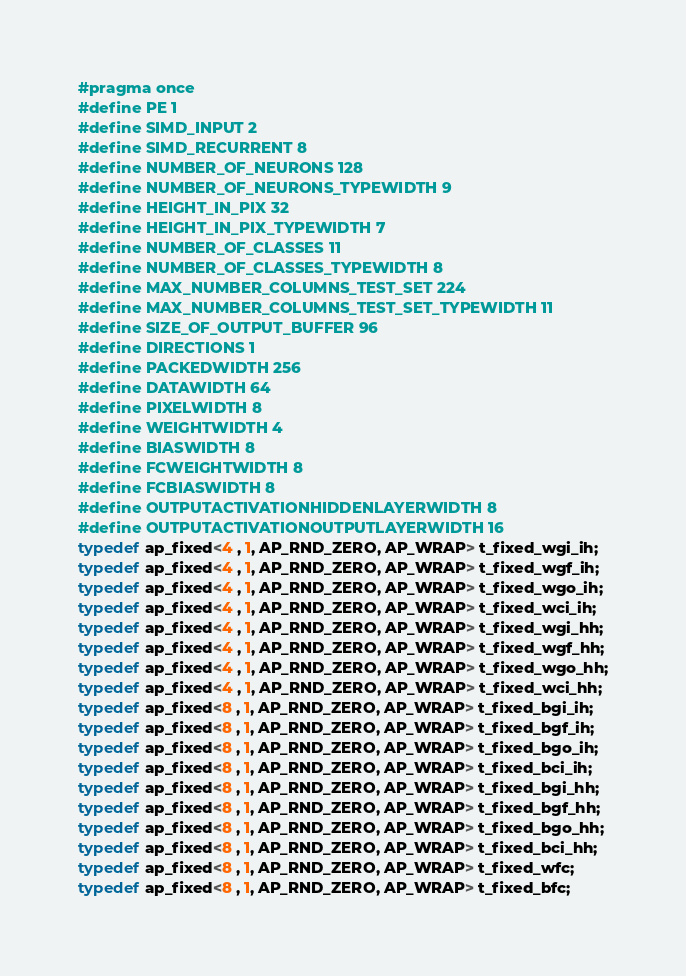<code> <loc_0><loc_0><loc_500><loc_500><_C++_>#pragma once
#define PE 1
#define SIMD_INPUT 2
#define SIMD_RECURRENT 8
#define NUMBER_OF_NEURONS 128
#define NUMBER_OF_NEURONS_TYPEWIDTH 9
#define HEIGHT_IN_PIX 32
#define HEIGHT_IN_PIX_TYPEWIDTH 7
#define NUMBER_OF_CLASSES 11
#define NUMBER_OF_CLASSES_TYPEWIDTH 8
#define MAX_NUMBER_COLUMNS_TEST_SET 224
#define MAX_NUMBER_COLUMNS_TEST_SET_TYPEWIDTH 11
#define SIZE_OF_OUTPUT_BUFFER 96
#define DIRECTIONS 1
#define PACKEDWIDTH 256
#define DATAWIDTH 64
#define PIXELWIDTH 8
#define WEIGHTWIDTH 4
#define BIASWIDTH 8
#define FCWEIGHTWIDTH 8
#define FCBIASWIDTH 8
#define OUTPUTACTIVATIONHIDDENLAYERWIDTH 8
#define OUTPUTACTIVATIONOUTPUTLAYERWIDTH 16
typedef ap_fixed<4 , 1, AP_RND_ZERO, AP_WRAP> t_fixed_wgi_ih;
typedef ap_fixed<4 , 1, AP_RND_ZERO, AP_WRAP> t_fixed_wgf_ih;
typedef ap_fixed<4 , 1, AP_RND_ZERO, AP_WRAP> t_fixed_wgo_ih;
typedef ap_fixed<4 , 1, AP_RND_ZERO, AP_WRAP> t_fixed_wci_ih;
typedef ap_fixed<4 , 1, AP_RND_ZERO, AP_WRAP> t_fixed_wgi_hh;
typedef ap_fixed<4 , 1, AP_RND_ZERO, AP_WRAP> t_fixed_wgf_hh;
typedef ap_fixed<4 , 1, AP_RND_ZERO, AP_WRAP> t_fixed_wgo_hh;
typedef ap_fixed<4 , 1, AP_RND_ZERO, AP_WRAP> t_fixed_wci_hh;
typedef ap_fixed<8 , 1, AP_RND_ZERO, AP_WRAP> t_fixed_bgi_ih;
typedef ap_fixed<8 , 1, AP_RND_ZERO, AP_WRAP> t_fixed_bgf_ih;
typedef ap_fixed<8 , 1, AP_RND_ZERO, AP_WRAP> t_fixed_bgo_ih;
typedef ap_fixed<8 , 1, AP_RND_ZERO, AP_WRAP> t_fixed_bci_ih;
typedef ap_fixed<8 , 1, AP_RND_ZERO, AP_WRAP> t_fixed_bgi_hh;
typedef ap_fixed<8 , 1, AP_RND_ZERO, AP_WRAP> t_fixed_bgf_hh;
typedef ap_fixed<8 , 1, AP_RND_ZERO, AP_WRAP> t_fixed_bgo_hh;
typedef ap_fixed<8 , 1, AP_RND_ZERO, AP_WRAP> t_fixed_bci_hh;
typedef ap_fixed<8 , 1, AP_RND_ZERO, AP_WRAP> t_fixed_wfc;
typedef ap_fixed<8 , 1, AP_RND_ZERO, AP_WRAP> t_fixed_bfc;</code> 